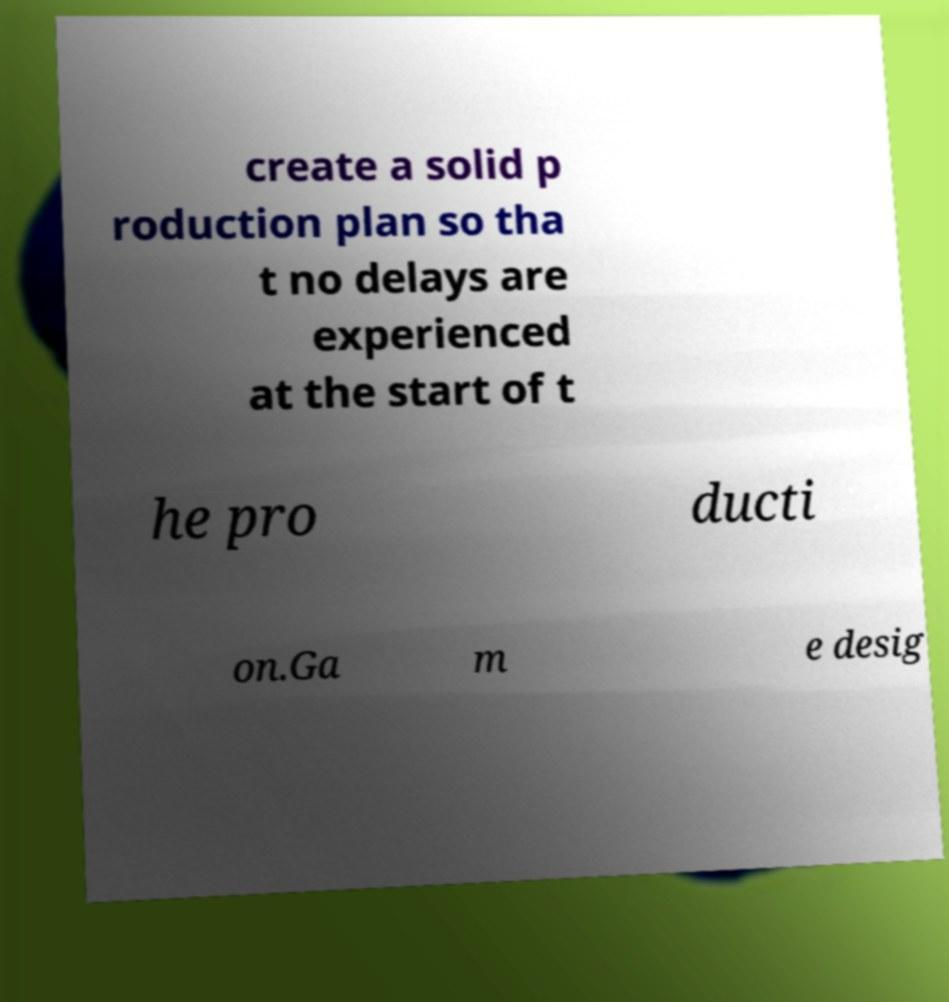Could you extract and type out the text from this image? create a solid p roduction plan so tha t no delays are experienced at the start of t he pro ducti on.Ga m e desig 